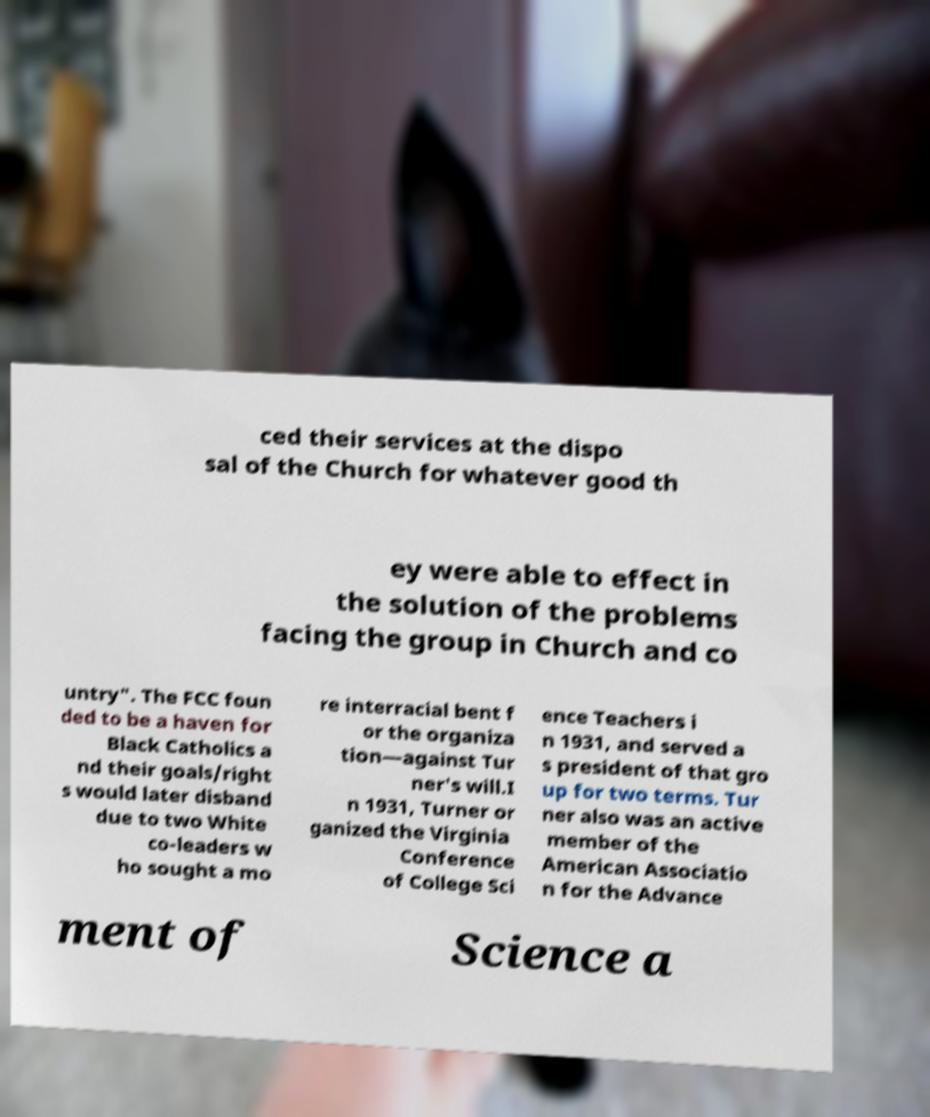For documentation purposes, I need the text within this image transcribed. Could you provide that? ced their services at the dispo sal of the Church for whatever good th ey were able to effect in the solution of the problems facing the group in Church and co untry". The FCC foun ded to be a haven for Black Catholics a nd their goals/right s would later disband due to two White co-leaders w ho sought a mo re interracial bent f or the organiza tion—against Tur ner's will.I n 1931, Turner or ganized the Virginia Conference of College Sci ence Teachers i n 1931, and served a s president of that gro up for two terms. Tur ner also was an active member of the American Associatio n for the Advance ment of Science a 